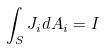Convert formula to latex. <formula><loc_0><loc_0><loc_500><loc_500>\int _ { S } J _ { i } d A _ { i } = I</formula> 